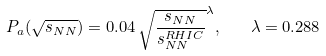<formula> <loc_0><loc_0><loc_500><loc_500>P _ { a } ( \sqrt { s _ { N N } } ) = 0 . 0 4 \, \sqrt { \frac { s _ { N N } } { s _ { N N } ^ { R H I C } } } ^ { \lambda } , \quad \lambda = 0 . 2 8 8</formula> 